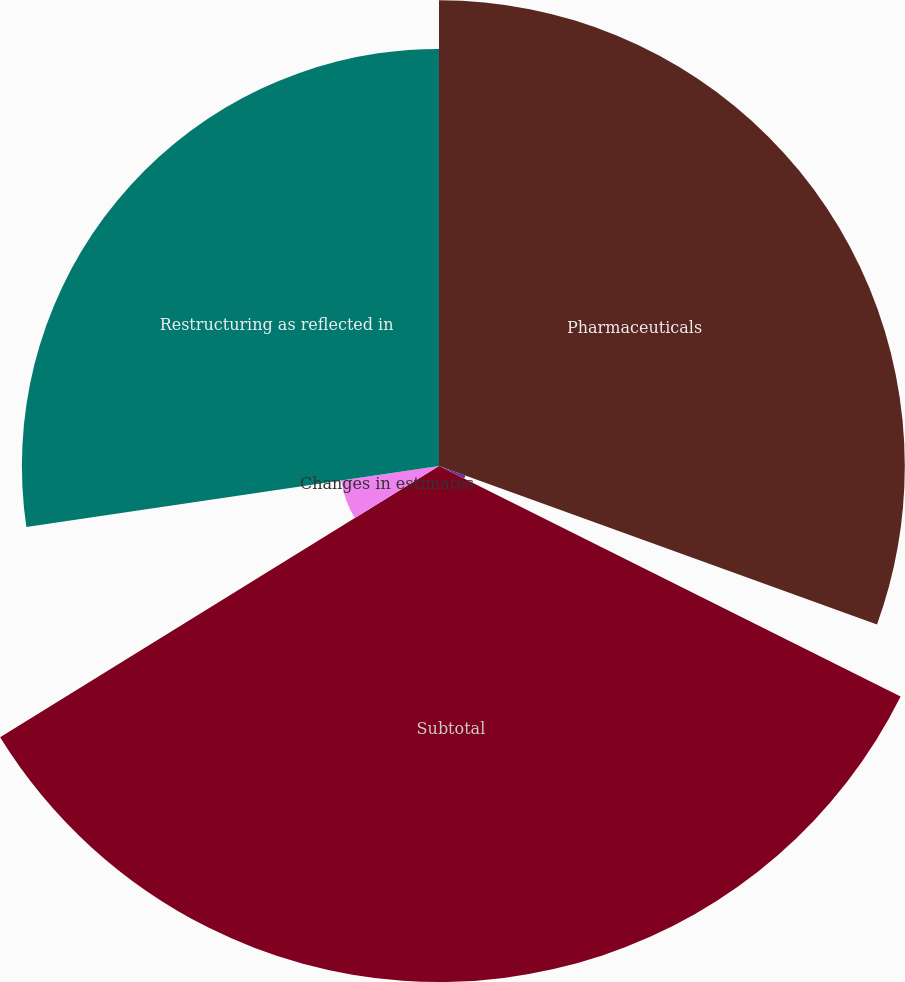Convert chart to OTSL. <chart><loc_0><loc_0><loc_500><loc_500><pie_chart><fcel>Pharmaceuticals<fcel>Nutritionals<fcel>Subtotal<fcel>Changes in estimates<fcel>Restructuring as reflected in<nl><fcel>30.52%<fcel>1.85%<fcel>33.81%<fcel>6.48%<fcel>27.33%<nl></chart> 